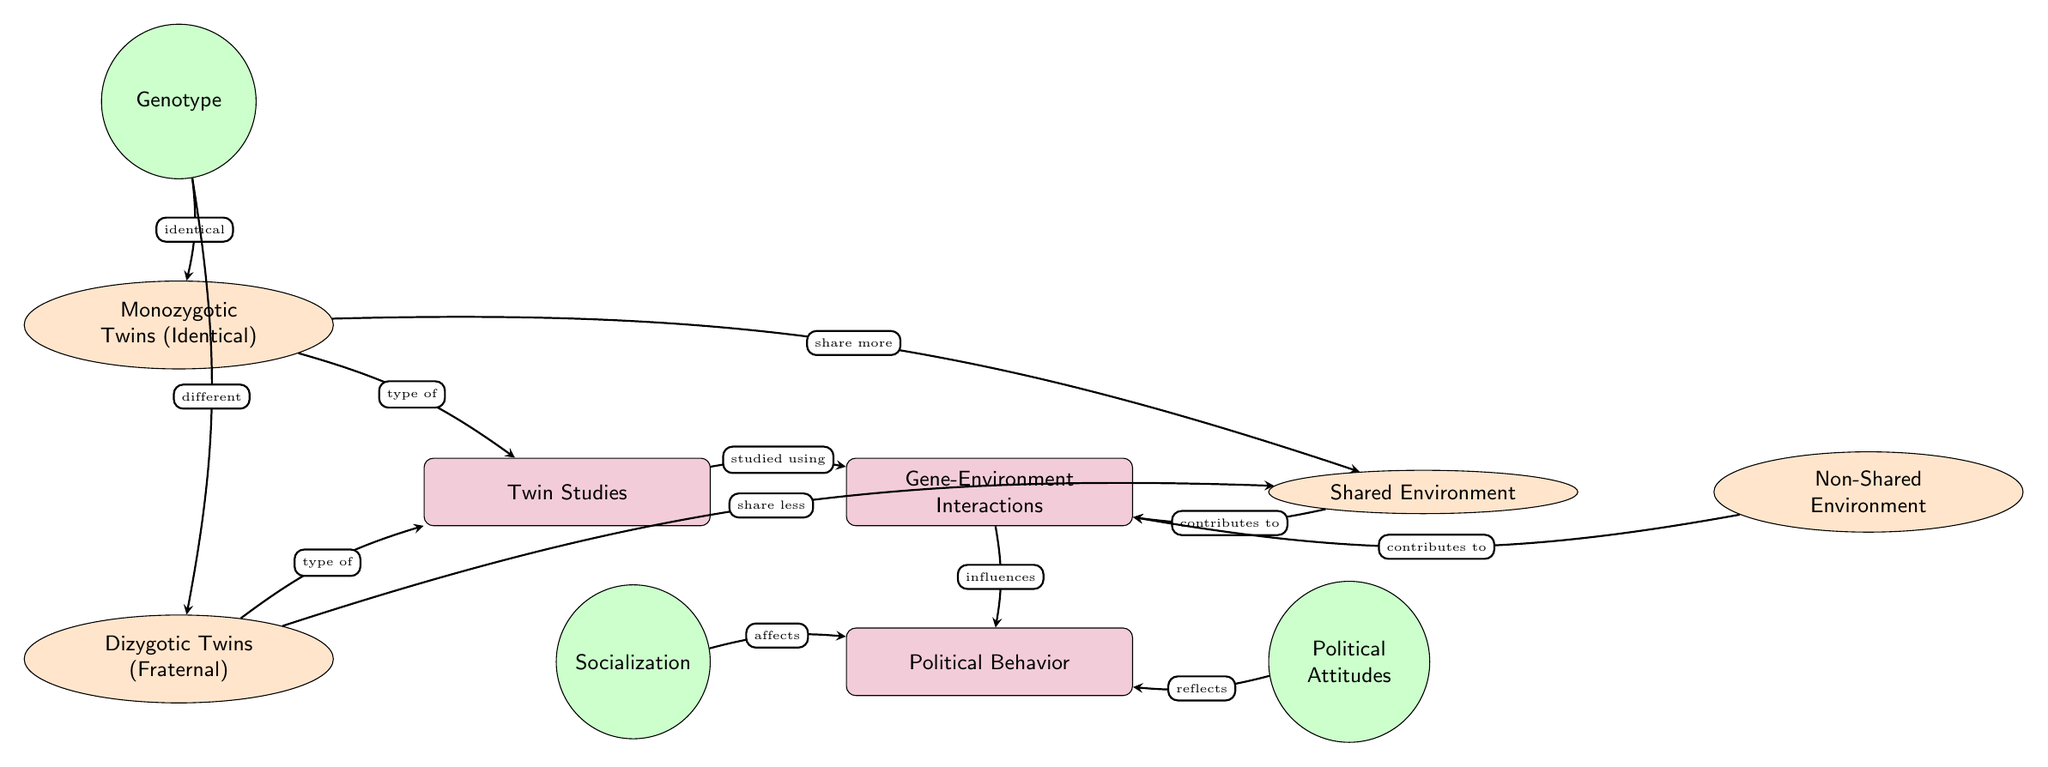What's the main topic of the diagram? The main node labeled "Gene-Environment Interactions" identifies the primary focus of the diagram, indicating that it addresses how genetics and environment interact to influence political behavior.
Answer: Gene-Environment Interactions How many types of twins are mentioned in the diagram? There are two sub-nodes for types of twins: "Monozygotic Twins (Identical)" and "Dizygotic Twins (Fraternal)", which totals to two types.
Answer: Two What type of twins share more of the shared environment? The arrow from "Monozygotic Twins (Identical)" to "Shared Environment" suggests that identical twins share more of the shared environment compared to fraternal twins.
Answer: Monozygotic Twins Which component affects Political Behavior according to the diagram? The node "Socialization" has an arrow directed towards "Political Behavior", indicating that socialization is a contributing factor to political behavior.
Answer: Socialization What are the two environments listed in the diagram? The diagram has nodes labeled "Shared Environment" and "Non-Shared Environment", indicating these two types of environments that play a role in gene-environment interactions.
Answer: Shared Environment, Non-Shared Environment Which node reflects Political Attitudes? The arrow directed from "Political Attitudes" to "Political Behavior" indicates that political attitudes provide a reflection or representation of political behavior.
Answer: Political Attitudes What is the relationship between Gene-Environment Interactions and Political Behavior? The diagram shows an arrow from "Gene-Environment Interactions" to "Political Behavior", indicating that gene-environment interactions influence political behavior.
Answer: Influences How do Dizygotic twins differ from Monozygotic twins based on the diagram? The diagram illustrates an arrow from "Dizygotic Twins (Fraternal)" that states they "share less" of the shared environment compared to monozygotic twins.
Answer: Share less What type of environment contributes to Gene-Environment Interactions? Both "Shared Environment" and "Non-Shared Environment" nodes have arrows pointing towards "Gene-Environment Interactions", indicating both contribute.
Answer: Shared Environment, Non-Shared Environment 